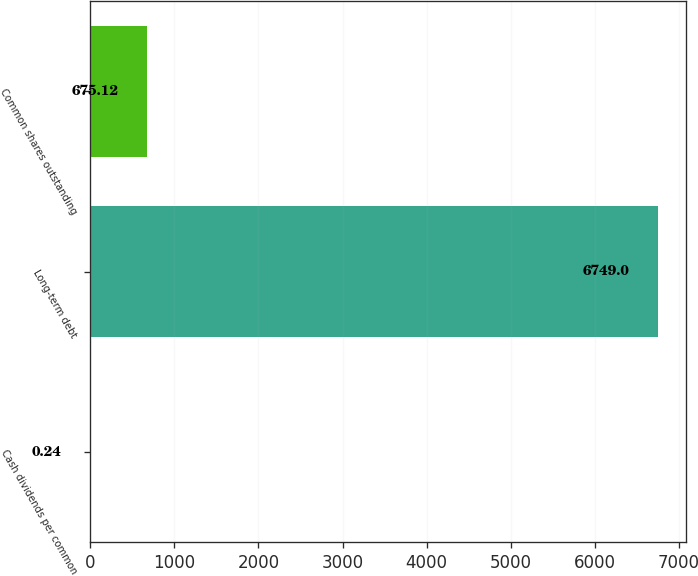Convert chart. <chart><loc_0><loc_0><loc_500><loc_500><bar_chart><fcel>Cash dividends per common<fcel>Long-term debt<fcel>Common shares outstanding<nl><fcel>0.24<fcel>6749<fcel>675.12<nl></chart> 